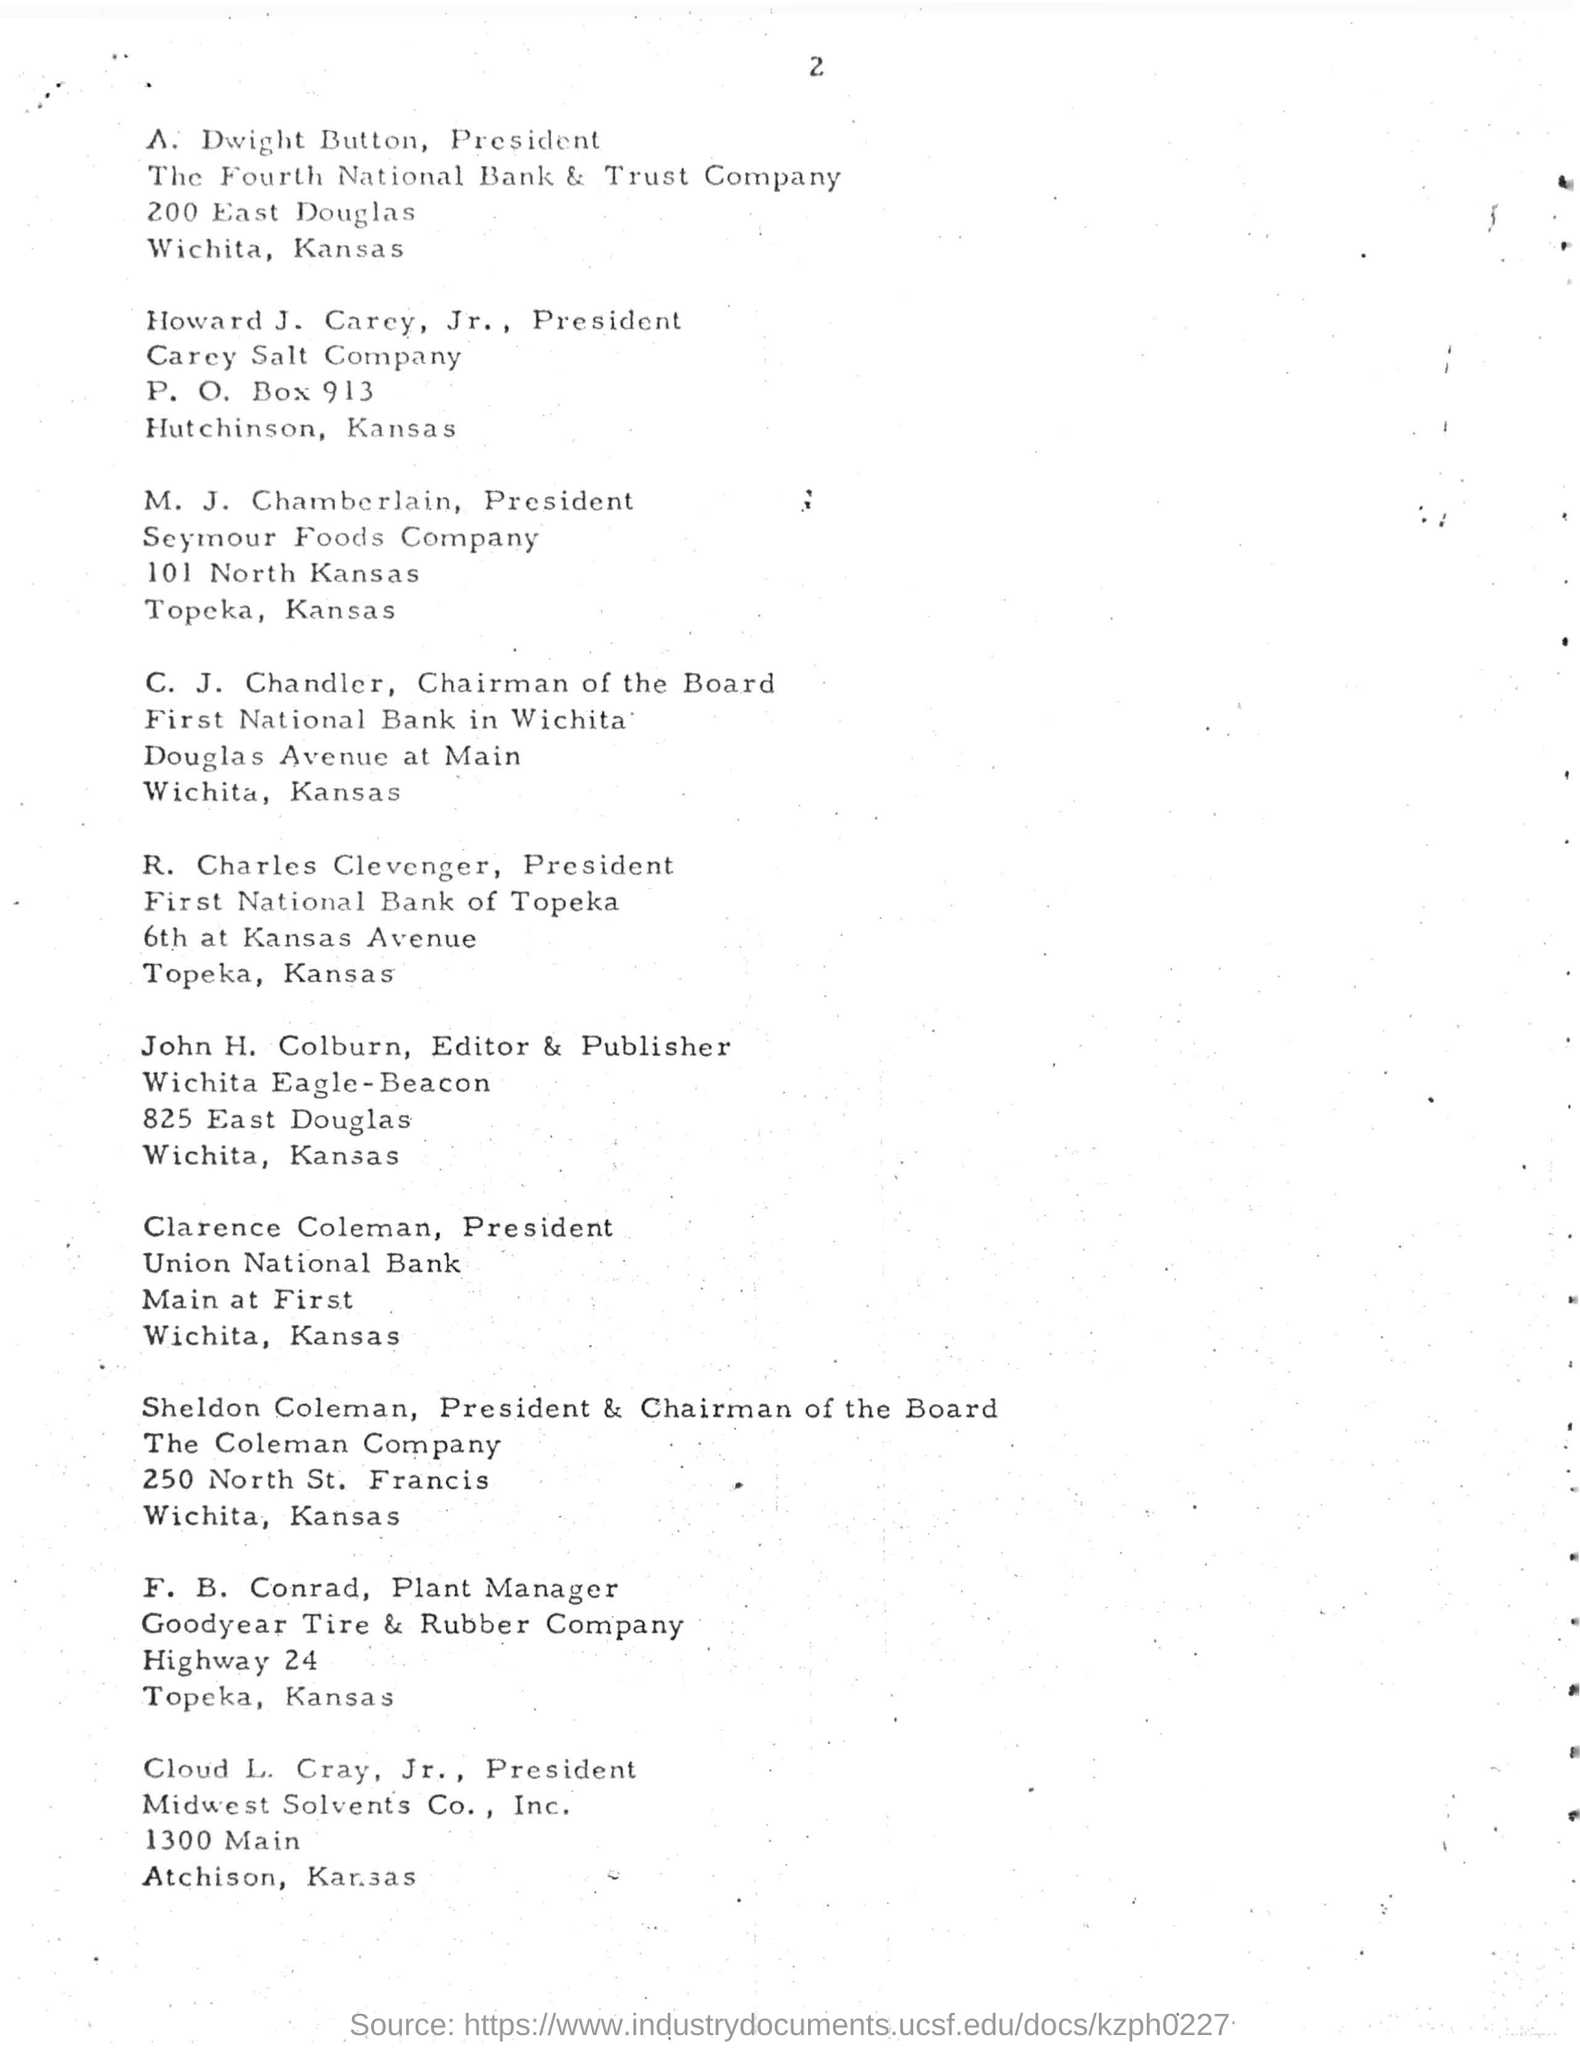Who is the plant manager of goodyear tire and rubber company ?
Keep it short and to the point. F. B. Conrad. A. Dwight button is the president of which company ?
Make the answer very short. The Fourth National Bank & Trust Company. What is the address mentioned for the seymour foods company ?
Make the answer very short. 101 North Kansas. What is the post of sheldon coleman in the coleman company ?
Keep it short and to the point. PRESIDENT & CHAIRMAN OF THE BOARD. Who is the president of first national bank of topeka?
Offer a terse response. R. Charles Clevenger. Who is the president of union national bank?
Provide a short and direct response. Clarence coleman. 